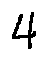Convert formula to latex. <formula><loc_0><loc_0><loc_500><loc_500>4</formula> 